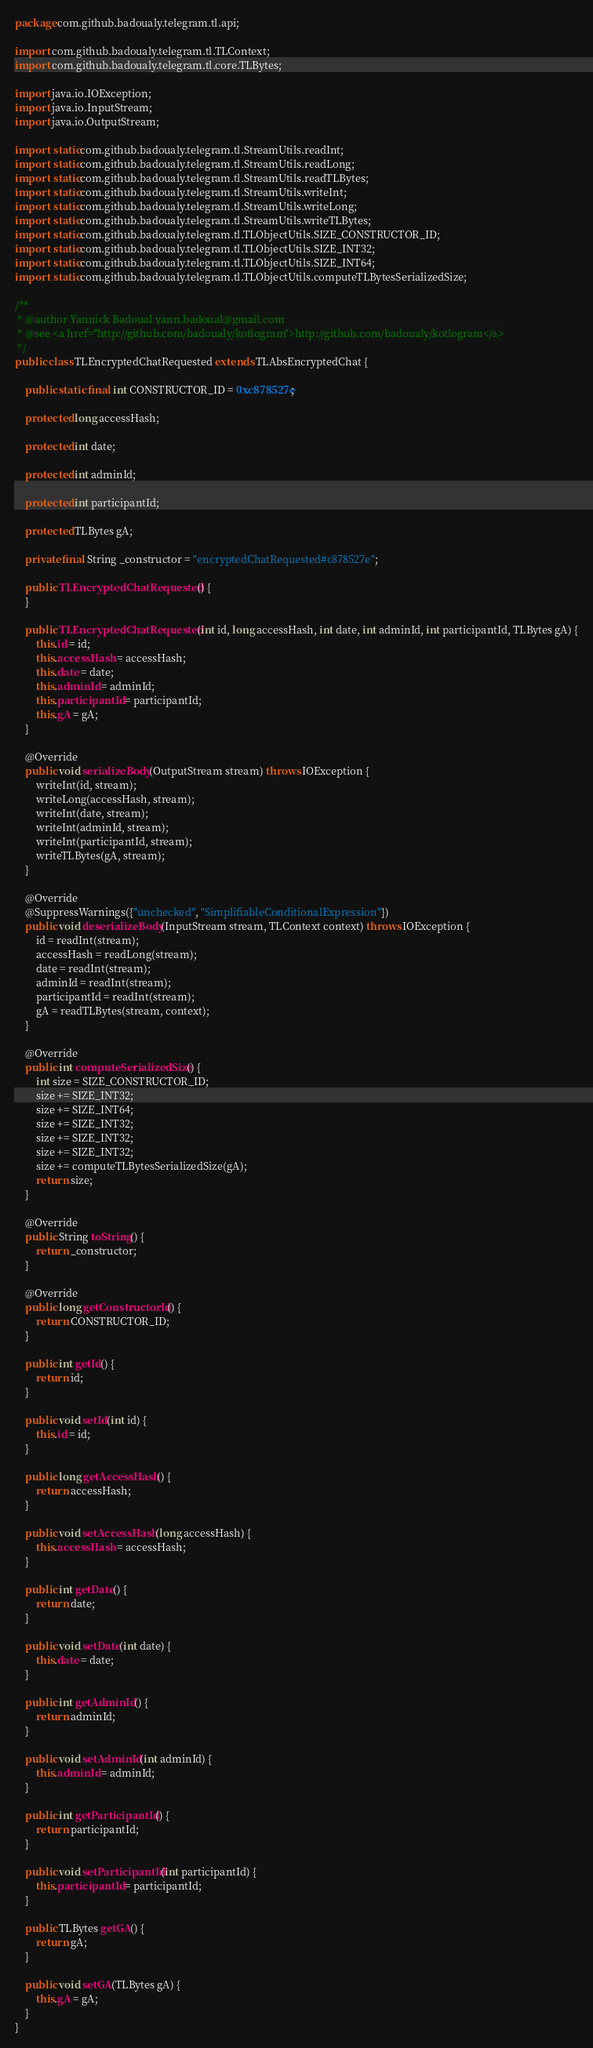<code> <loc_0><loc_0><loc_500><loc_500><_Java_>package com.github.badoualy.telegram.tl.api;

import com.github.badoualy.telegram.tl.TLContext;
import com.github.badoualy.telegram.tl.core.TLBytes;

import java.io.IOException;
import java.io.InputStream;
import java.io.OutputStream;

import static com.github.badoualy.telegram.tl.StreamUtils.readInt;
import static com.github.badoualy.telegram.tl.StreamUtils.readLong;
import static com.github.badoualy.telegram.tl.StreamUtils.readTLBytes;
import static com.github.badoualy.telegram.tl.StreamUtils.writeInt;
import static com.github.badoualy.telegram.tl.StreamUtils.writeLong;
import static com.github.badoualy.telegram.tl.StreamUtils.writeTLBytes;
import static com.github.badoualy.telegram.tl.TLObjectUtils.SIZE_CONSTRUCTOR_ID;
import static com.github.badoualy.telegram.tl.TLObjectUtils.SIZE_INT32;
import static com.github.badoualy.telegram.tl.TLObjectUtils.SIZE_INT64;
import static com.github.badoualy.telegram.tl.TLObjectUtils.computeTLBytesSerializedSize;

/**
 * @author Yannick Badoual yann.badoual@gmail.com
 * @see <a href="http://github.com/badoualy/kotlogram">http://github.com/badoualy/kotlogram</a>
 */
public class TLEncryptedChatRequested extends TLAbsEncryptedChat {

    public static final int CONSTRUCTOR_ID = 0xc878527e;

    protected long accessHash;

    protected int date;

    protected int adminId;

    protected int participantId;

    protected TLBytes gA;

    private final String _constructor = "encryptedChatRequested#c878527e";

    public TLEncryptedChatRequested() {
    }

    public TLEncryptedChatRequested(int id, long accessHash, int date, int adminId, int participantId, TLBytes gA) {
        this.id = id;
        this.accessHash = accessHash;
        this.date = date;
        this.adminId = adminId;
        this.participantId = participantId;
        this.gA = gA;
    }

    @Override
    public void serializeBody(OutputStream stream) throws IOException {
        writeInt(id, stream);
        writeLong(accessHash, stream);
        writeInt(date, stream);
        writeInt(adminId, stream);
        writeInt(participantId, stream);
        writeTLBytes(gA, stream);
    }

    @Override
    @SuppressWarnings({"unchecked", "SimplifiableConditionalExpression"})
    public void deserializeBody(InputStream stream, TLContext context) throws IOException {
        id = readInt(stream);
        accessHash = readLong(stream);
        date = readInt(stream);
        adminId = readInt(stream);
        participantId = readInt(stream);
        gA = readTLBytes(stream, context);
    }

    @Override
    public int computeSerializedSize() {
        int size = SIZE_CONSTRUCTOR_ID;
        size += SIZE_INT32;
        size += SIZE_INT64;
        size += SIZE_INT32;
        size += SIZE_INT32;
        size += SIZE_INT32;
        size += computeTLBytesSerializedSize(gA);
        return size;
    }

    @Override
    public String toString() {
        return _constructor;
    }

    @Override
    public long getConstructorId() {
        return CONSTRUCTOR_ID;
    }

    public int getId() {
        return id;
    }

    public void setId(int id) {
        this.id = id;
    }

    public long getAccessHash() {
        return accessHash;
    }

    public void setAccessHash(long accessHash) {
        this.accessHash = accessHash;
    }

    public int getDate() {
        return date;
    }

    public void setDate(int date) {
        this.date = date;
    }

    public int getAdminId() {
        return adminId;
    }

    public void setAdminId(int adminId) {
        this.adminId = adminId;
    }

    public int getParticipantId() {
        return participantId;
    }

    public void setParticipantId(int participantId) {
        this.participantId = participantId;
    }

    public TLBytes getGA() {
        return gA;
    }

    public void setGA(TLBytes gA) {
        this.gA = gA;
    }
}
</code> 